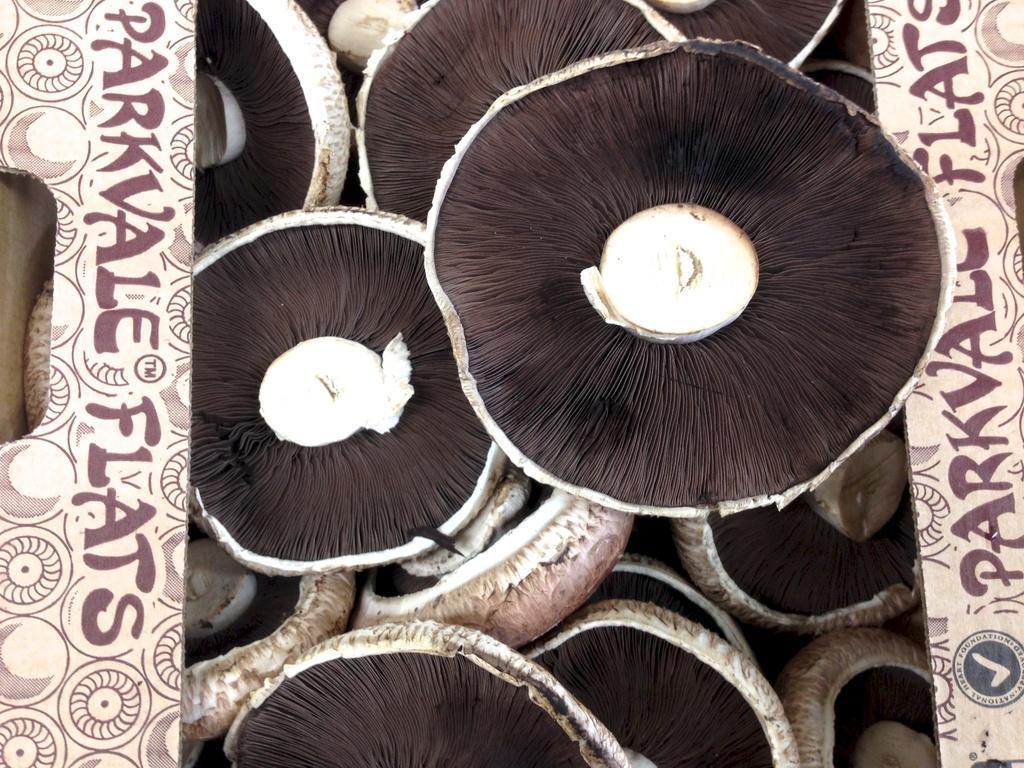Can you describe this image briefly? In this picture there are mushrooms in the cardboard box and there is text on the cardboard box and the mushrooms are in brown and cream color. 